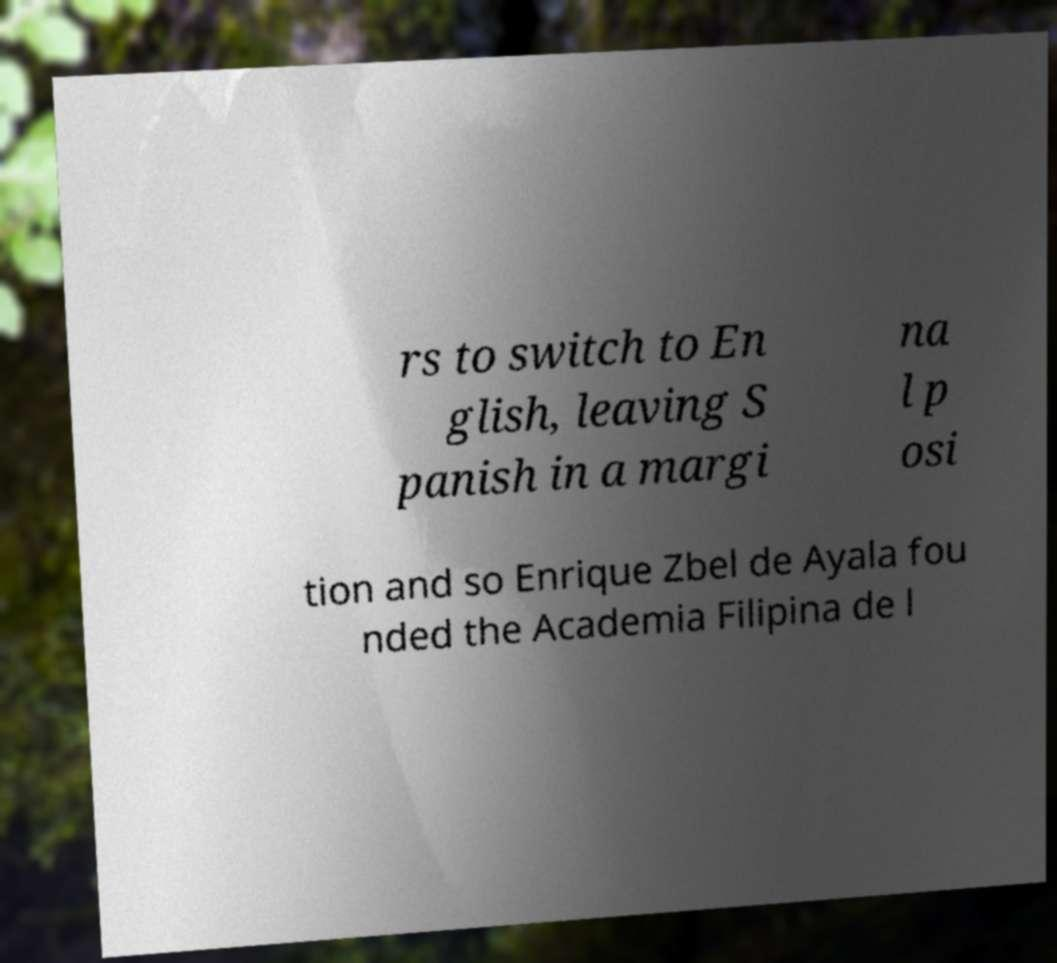I need the written content from this picture converted into text. Can you do that? rs to switch to En glish, leaving S panish in a margi na l p osi tion and so Enrique Zbel de Ayala fou nded the Academia Filipina de l 